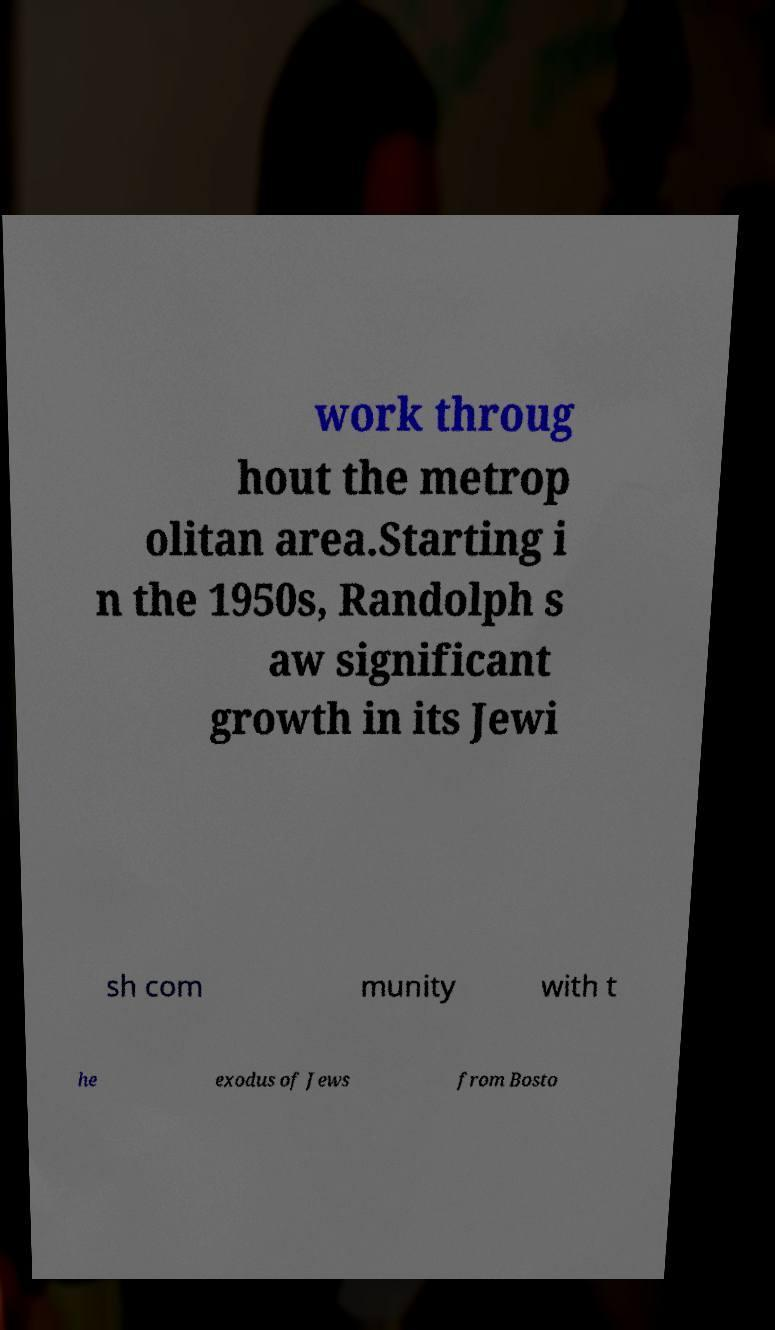I need the written content from this picture converted into text. Can you do that? work throug hout the metrop olitan area.Starting i n the 1950s, Randolph s aw significant growth in its Jewi sh com munity with t he exodus of Jews from Bosto 